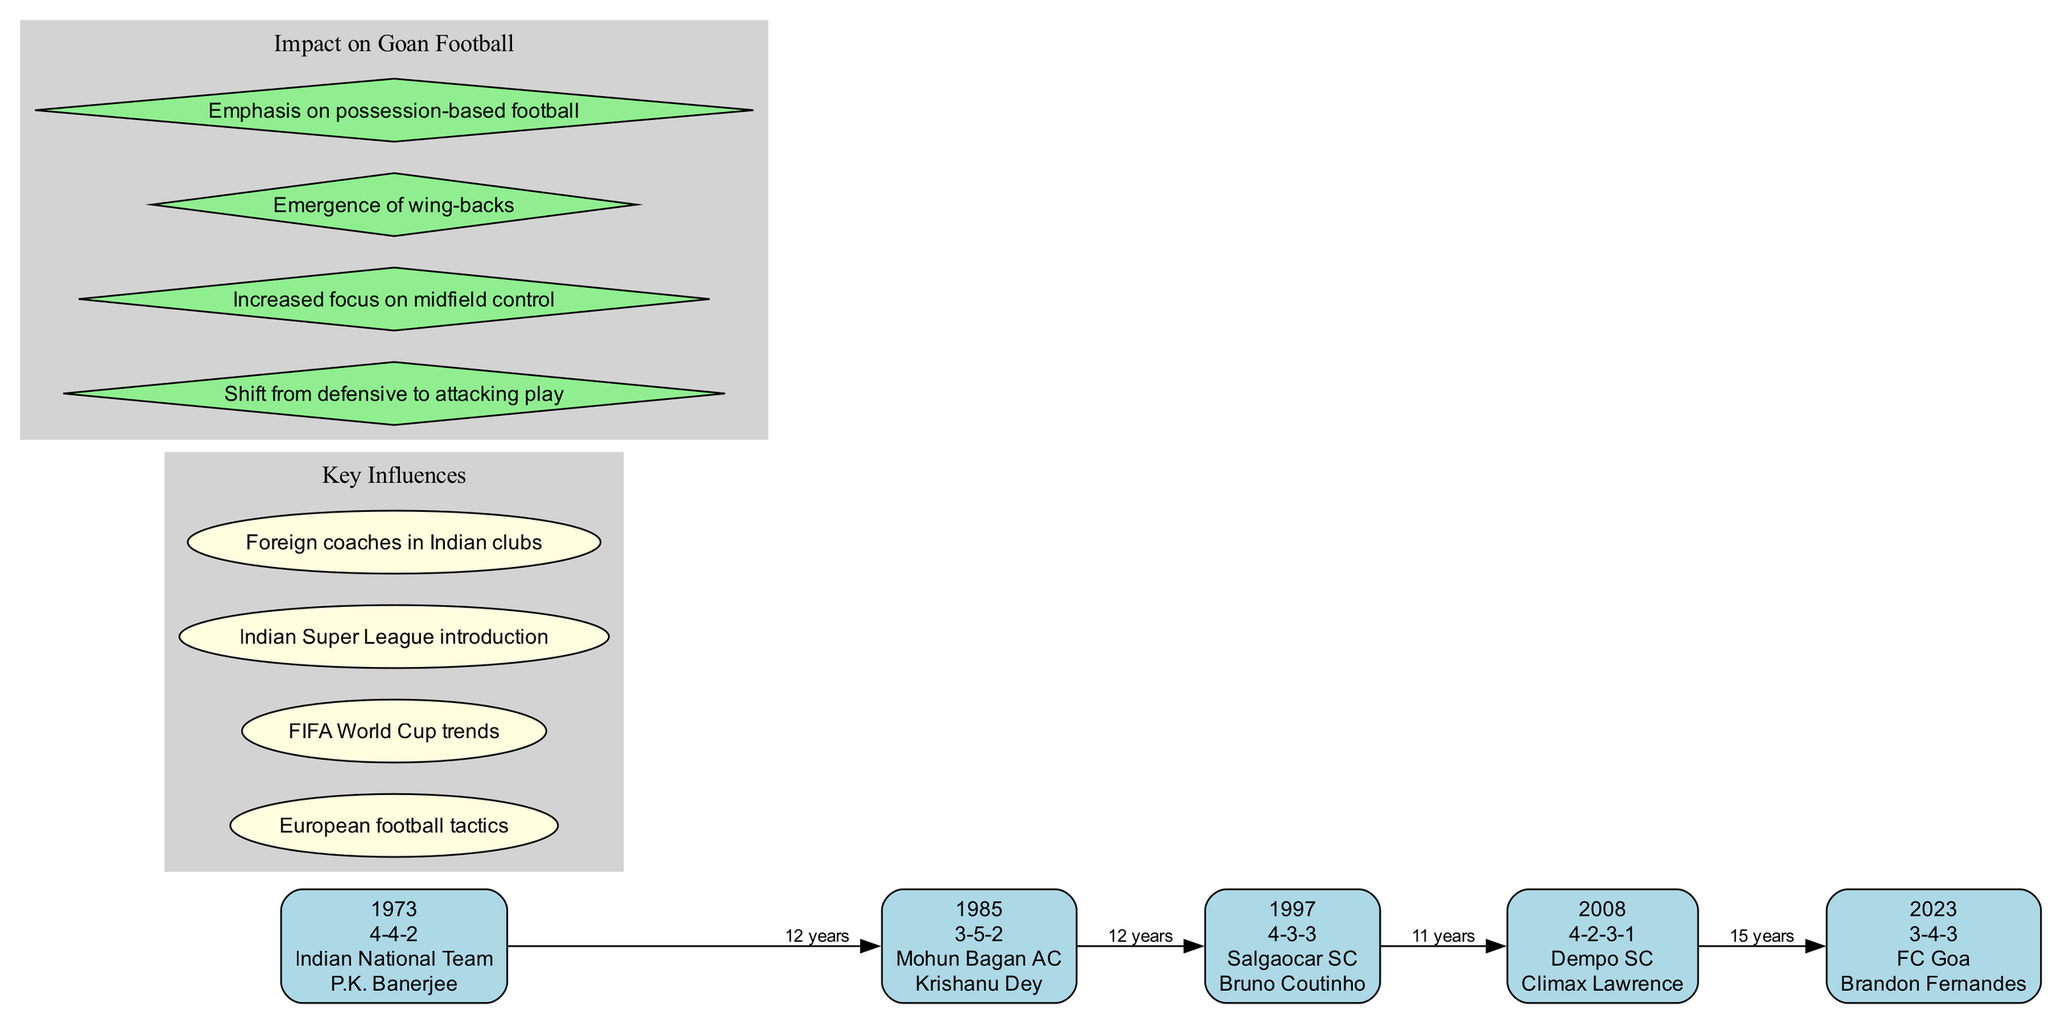What was the tactical formation used by the Indian National Team in 1973? The diagram shows that in 1973, the Indian National Team used the 4-4-2 formation. This information is located in the node for the year 1973.
Answer: 4-4-2 Which team adopted the 3-5-2 formation in 1985? According to the diagram, Mohun Bagan AC adopted the 3-5-2 formation in 1985, as indicated in the corresponding node for that year.
Answer: Mohun Bagan AC List one notable player from Salgaocar SC in 1997? The diagram states that Bruno Coutinho was a notable player from Salgaocar SC in 1997, as noted in the node representing that year.
Answer: Bruno Coutinho How many years are there between the formation changes from 1997 to 2008? By examining the timeline, 2008 and 1997 represent an 11-year gap, as calculated by subtracting the two years.
Answer: 11 years Which tactical formation was introduced in 2023? The diagram clearly indicates that the tactical formation used by FC Goa in 2023 is 3-4-3, as noted in the relevant node for that year.
Answer: 3-4-3 What influence helped shift Indian football tactics towards more attacking play? The diagram includes "Shift from defensive to attacking play" as one of the impacts on Goan football, demonstrating that this is a direct influence noted under the impacts section.
Answer: Shift from defensive to attacking play What is one key influence mentioned in the diagram? From the diagram, one of the key influences is "Indian Super League introduction," which is listed under the influences section.
Answer: Indian Super League introduction How has the focus on midfield control changed over the years? The diagram indicates an "Increased focus on midfield control" as a significant change impacting Goan football, representing a trend from past formations to current strategies.
Answer: Increased focus on midfield control Which formation is associated with Dempo SC in 2008? The diagram specifies that Dempo SC used the 4-2-3-1 formation in 2008, as mentioned in that specific year’s node.
Answer: 4-2-3-1 